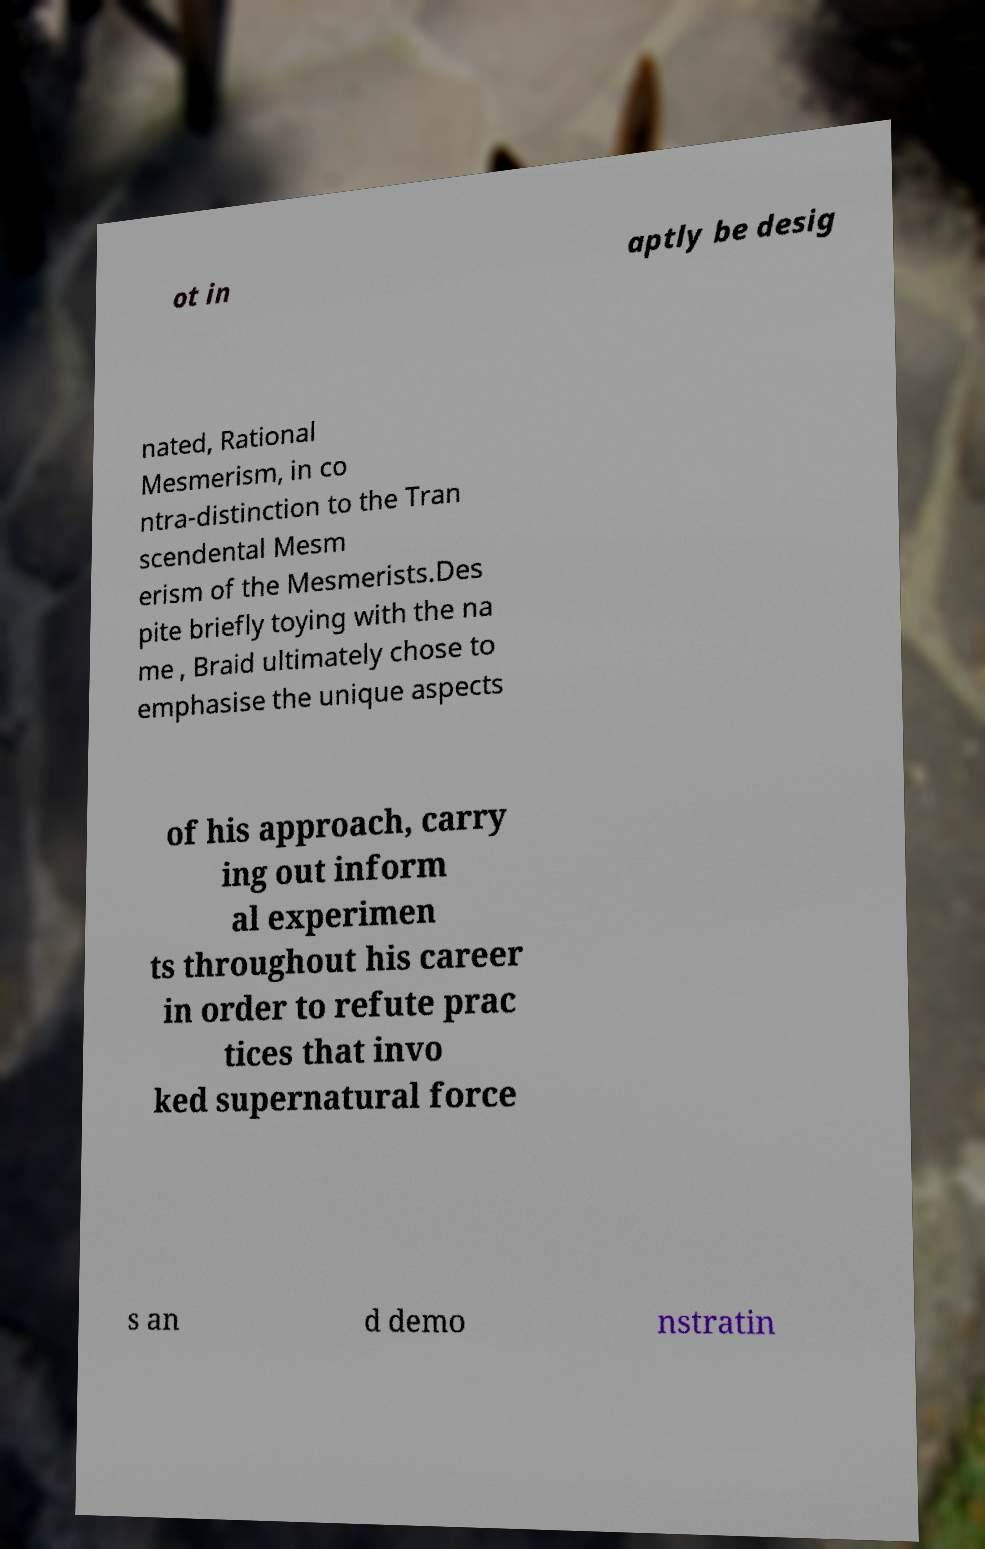For documentation purposes, I need the text within this image transcribed. Could you provide that? ot in aptly be desig nated, Rational Mesmerism, in co ntra-distinction to the Tran scendental Mesm erism of the Mesmerists.Des pite briefly toying with the na me , Braid ultimately chose to emphasise the unique aspects of his approach, carry ing out inform al experimen ts throughout his career in order to refute prac tices that invo ked supernatural force s an d demo nstratin 